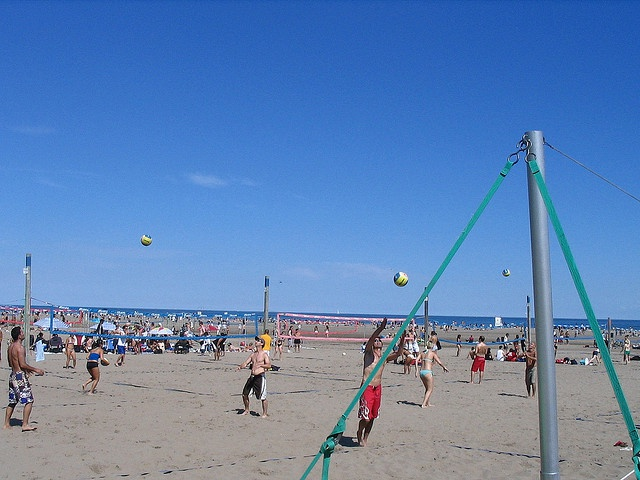Describe the objects in this image and their specific colors. I can see people in blue, darkgray, gray, black, and lightgray tones, people in blue, gray, black, and darkgray tones, people in blue, black, maroon, gray, and darkgray tones, people in blue, black, darkgray, pink, and gray tones, and people in blue, darkgray, pink, and gray tones in this image. 